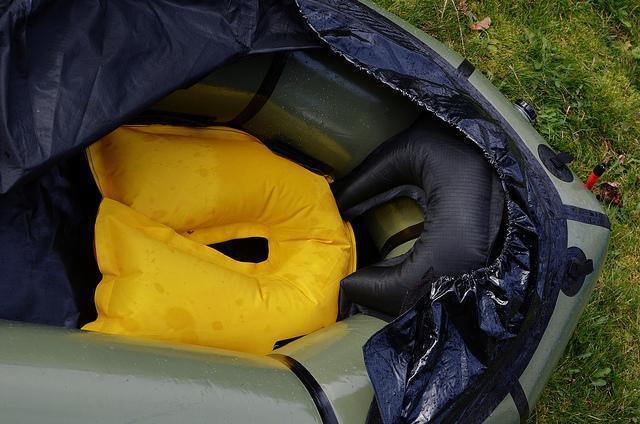How many cats are on the umbrella?
Give a very brief answer. 0. 